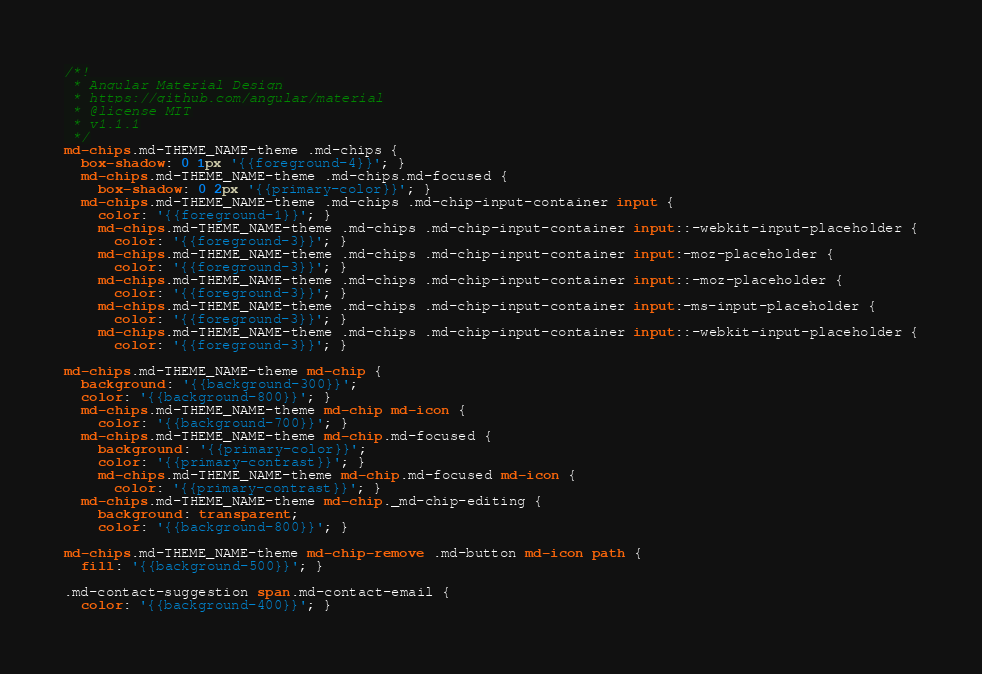Convert code to text. <code><loc_0><loc_0><loc_500><loc_500><_CSS_>/*!
 * Angular Material Design
 * https://github.com/angular/material
 * @license MIT
 * v1.1.1
 */
md-chips.md-THEME_NAME-theme .md-chips {
  box-shadow: 0 1px '{{foreground-4}}'; }
  md-chips.md-THEME_NAME-theme .md-chips.md-focused {
    box-shadow: 0 2px '{{primary-color}}'; }
  md-chips.md-THEME_NAME-theme .md-chips .md-chip-input-container input {
    color: '{{foreground-1}}'; }
    md-chips.md-THEME_NAME-theme .md-chips .md-chip-input-container input::-webkit-input-placeholder {
      color: '{{foreground-3}}'; }
    md-chips.md-THEME_NAME-theme .md-chips .md-chip-input-container input:-moz-placeholder {
      color: '{{foreground-3}}'; }
    md-chips.md-THEME_NAME-theme .md-chips .md-chip-input-container input::-moz-placeholder {
      color: '{{foreground-3}}'; }
    md-chips.md-THEME_NAME-theme .md-chips .md-chip-input-container input:-ms-input-placeholder {
      color: '{{foreground-3}}'; }
    md-chips.md-THEME_NAME-theme .md-chips .md-chip-input-container input::-webkit-input-placeholder {
      color: '{{foreground-3}}'; }

md-chips.md-THEME_NAME-theme md-chip {
  background: '{{background-300}}';
  color: '{{background-800}}'; }
  md-chips.md-THEME_NAME-theme md-chip md-icon {
    color: '{{background-700}}'; }
  md-chips.md-THEME_NAME-theme md-chip.md-focused {
    background: '{{primary-color}}';
    color: '{{primary-contrast}}'; }
    md-chips.md-THEME_NAME-theme md-chip.md-focused md-icon {
      color: '{{primary-contrast}}'; }
  md-chips.md-THEME_NAME-theme md-chip._md-chip-editing {
    background: transparent;
    color: '{{background-800}}'; }

md-chips.md-THEME_NAME-theme md-chip-remove .md-button md-icon path {
  fill: '{{background-500}}'; }

.md-contact-suggestion span.md-contact-email {
  color: '{{background-400}}'; }
</code> 